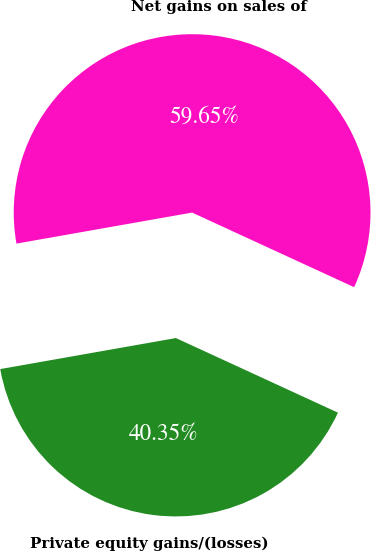Convert chart. <chart><loc_0><loc_0><loc_500><loc_500><pie_chart><fcel>Private equity gains/(losses)<fcel>Net gains on sales of<nl><fcel>40.35%<fcel>59.65%<nl></chart> 